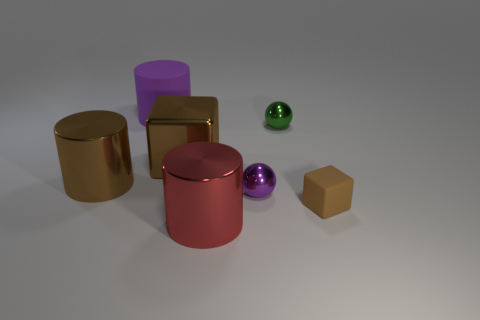Do the tiny block and the large block have the same color?
Keep it short and to the point. Yes. Is the number of purple objects that are on the right side of the big red cylinder less than the number of green metal balls?
Offer a very short reply. No. The big thing that is left of the purple cylinder is what color?
Offer a very short reply. Brown. The big red metallic object is what shape?
Your answer should be compact. Cylinder. There is a brown cube left of the purple thing in front of the small green metallic sphere; is there a small purple sphere behind it?
Your answer should be very brief. No. There is a large metallic thing that is in front of the large metallic cylinder that is behind the large cylinder to the right of the matte cylinder; what color is it?
Provide a succinct answer. Red. There is a purple thing that is the same shape as the red shiny object; what is its material?
Offer a terse response. Rubber. There is a rubber object that is to the right of the large cylinder that is in front of the big brown cylinder; how big is it?
Offer a very short reply. Small. What material is the large cylinder in front of the purple ball?
Make the answer very short. Metal. There is a brown cube that is the same material as the large purple object; what is its size?
Your answer should be very brief. Small. 